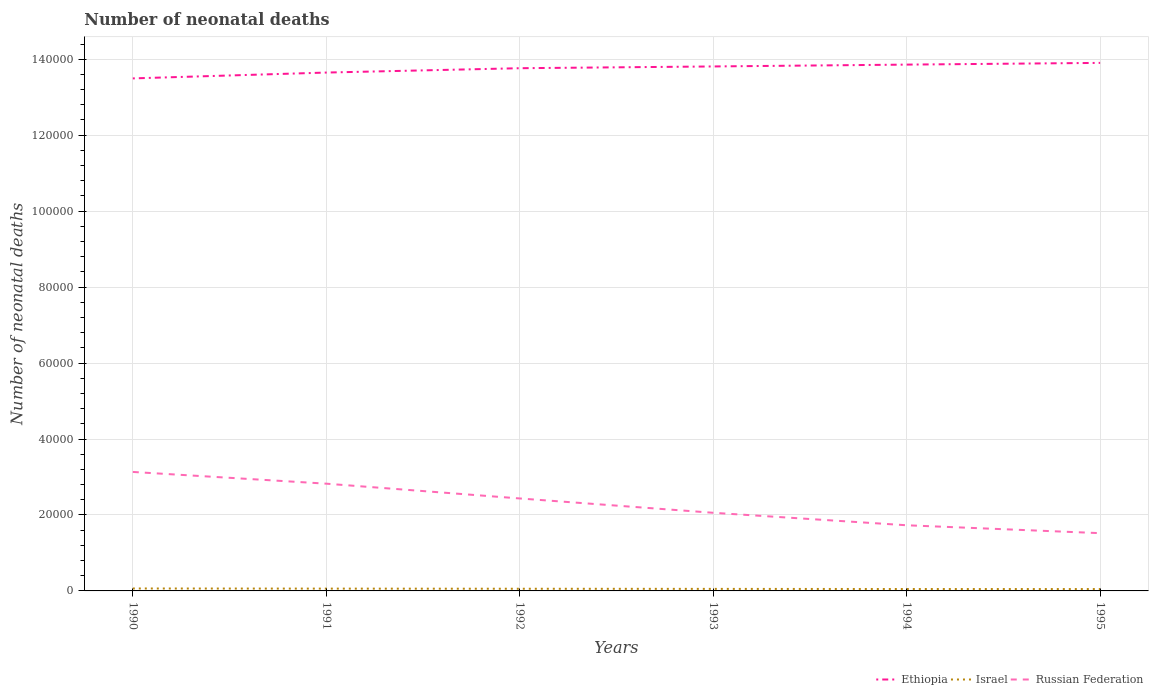How many different coloured lines are there?
Your answer should be very brief. 3. Across all years, what is the maximum number of neonatal deaths in in Israel?
Ensure brevity in your answer.  492. In which year was the number of neonatal deaths in in Israel maximum?
Provide a succinct answer. 1995. What is the total number of neonatal deaths in in Ethiopia in the graph?
Provide a succinct answer. -4085. What is the difference between the highest and the second highest number of neonatal deaths in in Israel?
Offer a very short reply. 151. Is the number of neonatal deaths in in Russian Federation strictly greater than the number of neonatal deaths in in Ethiopia over the years?
Ensure brevity in your answer.  Yes. How many lines are there?
Provide a short and direct response. 3. How many years are there in the graph?
Provide a short and direct response. 6. Are the values on the major ticks of Y-axis written in scientific E-notation?
Offer a very short reply. No. Does the graph contain any zero values?
Provide a short and direct response. No. Does the graph contain grids?
Your response must be concise. Yes. Where does the legend appear in the graph?
Provide a succinct answer. Bottom right. How are the legend labels stacked?
Offer a terse response. Horizontal. What is the title of the graph?
Give a very brief answer. Number of neonatal deaths. Does "Cote d'Ivoire" appear as one of the legend labels in the graph?
Your answer should be compact. No. What is the label or title of the X-axis?
Your response must be concise. Years. What is the label or title of the Y-axis?
Offer a very short reply. Number of neonatal deaths. What is the Number of neonatal deaths in Ethiopia in 1990?
Keep it short and to the point. 1.35e+05. What is the Number of neonatal deaths in Israel in 1990?
Offer a very short reply. 643. What is the Number of neonatal deaths in Russian Federation in 1990?
Offer a very short reply. 3.13e+04. What is the Number of neonatal deaths in Ethiopia in 1991?
Provide a short and direct response. 1.36e+05. What is the Number of neonatal deaths in Israel in 1991?
Your response must be concise. 607. What is the Number of neonatal deaths in Russian Federation in 1991?
Provide a succinct answer. 2.82e+04. What is the Number of neonatal deaths of Ethiopia in 1992?
Your response must be concise. 1.38e+05. What is the Number of neonatal deaths in Israel in 1992?
Keep it short and to the point. 572. What is the Number of neonatal deaths in Russian Federation in 1992?
Make the answer very short. 2.43e+04. What is the Number of neonatal deaths in Ethiopia in 1993?
Keep it short and to the point. 1.38e+05. What is the Number of neonatal deaths of Israel in 1993?
Your answer should be very brief. 536. What is the Number of neonatal deaths in Russian Federation in 1993?
Offer a very short reply. 2.06e+04. What is the Number of neonatal deaths in Ethiopia in 1994?
Give a very brief answer. 1.39e+05. What is the Number of neonatal deaths in Israel in 1994?
Your response must be concise. 502. What is the Number of neonatal deaths in Russian Federation in 1994?
Your answer should be compact. 1.73e+04. What is the Number of neonatal deaths in Ethiopia in 1995?
Offer a very short reply. 1.39e+05. What is the Number of neonatal deaths of Israel in 1995?
Ensure brevity in your answer.  492. What is the Number of neonatal deaths of Russian Federation in 1995?
Provide a succinct answer. 1.52e+04. Across all years, what is the maximum Number of neonatal deaths in Ethiopia?
Provide a succinct answer. 1.39e+05. Across all years, what is the maximum Number of neonatal deaths in Israel?
Make the answer very short. 643. Across all years, what is the maximum Number of neonatal deaths of Russian Federation?
Your answer should be very brief. 3.13e+04. Across all years, what is the minimum Number of neonatal deaths in Ethiopia?
Provide a succinct answer. 1.35e+05. Across all years, what is the minimum Number of neonatal deaths in Israel?
Ensure brevity in your answer.  492. Across all years, what is the minimum Number of neonatal deaths in Russian Federation?
Provide a succinct answer. 1.52e+04. What is the total Number of neonatal deaths of Ethiopia in the graph?
Your answer should be compact. 8.25e+05. What is the total Number of neonatal deaths in Israel in the graph?
Offer a very short reply. 3352. What is the total Number of neonatal deaths in Russian Federation in the graph?
Offer a terse response. 1.37e+05. What is the difference between the Number of neonatal deaths of Ethiopia in 1990 and that in 1991?
Keep it short and to the point. -1538. What is the difference between the Number of neonatal deaths of Israel in 1990 and that in 1991?
Offer a terse response. 36. What is the difference between the Number of neonatal deaths in Russian Federation in 1990 and that in 1991?
Ensure brevity in your answer.  3089. What is the difference between the Number of neonatal deaths in Ethiopia in 1990 and that in 1992?
Provide a short and direct response. -2683. What is the difference between the Number of neonatal deaths in Russian Federation in 1990 and that in 1992?
Your answer should be very brief. 6981. What is the difference between the Number of neonatal deaths of Ethiopia in 1990 and that in 1993?
Your response must be concise. -3147. What is the difference between the Number of neonatal deaths in Israel in 1990 and that in 1993?
Your answer should be very brief. 107. What is the difference between the Number of neonatal deaths of Russian Federation in 1990 and that in 1993?
Your answer should be compact. 1.08e+04. What is the difference between the Number of neonatal deaths of Ethiopia in 1990 and that in 1994?
Offer a very short reply. -3631. What is the difference between the Number of neonatal deaths in Israel in 1990 and that in 1994?
Your response must be concise. 141. What is the difference between the Number of neonatal deaths of Russian Federation in 1990 and that in 1994?
Make the answer very short. 1.40e+04. What is the difference between the Number of neonatal deaths of Ethiopia in 1990 and that in 1995?
Make the answer very short. -4085. What is the difference between the Number of neonatal deaths of Israel in 1990 and that in 1995?
Your answer should be very brief. 151. What is the difference between the Number of neonatal deaths of Russian Federation in 1990 and that in 1995?
Your answer should be compact. 1.61e+04. What is the difference between the Number of neonatal deaths in Ethiopia in 1991 and that in 1992?
Offer a terse response. -1145. What is the difference between the Number of neonatal deaths in Russian Federation in 1991 and that in 1992?
Give a very brief answer. 3892. What is the difference between the Number of neonatal deaths of Ethiopia in 1991 and that in 1993?
Your answer should be very brief. -1609. What is the difference between the Number of neonatal deaths of Russian Federation in 1991 and that in 1993?
Provide a short and direct response. 7664. What is the difference between the Number of neonatal deaths in Ethiopia in 1991 and that in 1994?
Keep it short and to the point. -2093. What is the difference between the Number of neonatal deaths in Israel in 1991 and that in 1994?
Your response must be concise. 105. What is the difference between the Number of neonatal deaths in Russian Federation in 1991 and that in 1994?
Your answer should be compact. 1.10e+04. What is the difference between the Number of neonatal deaths of Ethiopia in 1991 and that in 1995?
Make the answer very short. -2547. What is the difference between the Number of neonatal deaths in Israel in 1991 and that in 1995?
Make the answer very short. 115. What is the difference between the Number of neonatal deaths of Russian Federation in 1991 and that in 1995?
Make the answer very short. 1.30e+04. What is the difference between the Number of neonatal deaths in Ethiopia in 1992 and that in 1993?
Your answer should be very brief. -464. What is the difference between the Number of neonatal deaths of Russian Federation in 1992 and that in 1993?
Keep it short and to the point. 3772. What is the difference between the Number of neonatal deaths in Ethiopia in 1992 and that in 1994?
Provide a short and direct response. -948. What is the difference between the Number of neonatal deaths in Russian Federation in 1992 and that in 1994?
Provide a succinct answer. 7059. What is the difference between the Number of neonatal deaths of Ethiopia in 1992 and that in 1995?
Provide a succinct answer. -1402. What is the difference between the Number of neonatal deaths in Russian Federation in 1992 and that in 1995?
Offer a very short reply. 9137. What is the difference between the Number of neonatal deaths in Ethiopia in 1993 and that in 1994?
Keep it short and to the point. -484. What is the difference between the Number of neonatal deaths of Russian Federation in 1993 and that in 1994?
Your answer should be compact. 3287. What is the difference between the Number of neonatal deaths of Ethiopia in 1993 and that in 1995?
Provide a short and direct response. -938. What is the difference between the Number of neonatal deaths of Russian Federation in 1993 and that in 1995?
Give a very brief answer. 5365. What is the difference between the Number of neonatal deaths of Ethiopia in 1994 and that in 1995?
Your answer should be compact. -454. What is the difference between the Number of neonatal deaths of Russian Federation in 1994 and that in 1995?
Provide a short and direct response. 2078. What is the difference between the Number of neonatal deaths of Ethiopia in 1990 and the Number of neonatal deaths of Israel in 1991?
Provide a succinct answer. 1.34e+05. What is the difference between the Number of neonatal deaths of Ethiopia in 1990 and the Number of neonatal deaths of Russian Federation in 1991?
Offer a very short reply. 1.07e+05. What is the difference between the Number of neonatal deaths in Israel in 1990 and the Number of neonatal deaths in Russian Federation in 1991?
Ensure brevity in your answer.  -2.76e+04. What is the difference between the Number of neonatal deaths in Ethiopia in 1990 and the Number of neonatal deaths in Israel in 1992?
Ensure brevity in your answer.  1.34e+05. What is the difference between the Number of neonatal deaths of Ethiopia in 1990 and the Number of neonatal deaths of Russian Federation in 1992?
Make the answer very short. 1.11e+05. What is the difference between the Number of neonatal deaths of Israel in 1990 and the Number of neonatal deaths of Russian Federation in 1992?
Keep it short and to the point. -2.37e+04. What is the difference between the Number of neonatal deaths of Ethiopia in 1990 and the Number of neonatal deaths of Israel in 1993?
Provide a short and direct response. 1.34e+05. What is the difference between the Number of neonatal deaths in Ethiopia in 1990 and the Number of neonatal deaths in Russian Federation in 1993?
Provide a succinct answer. 1.14e+05. What is the difference between the Number of neonatal deaths of Israel in 1990 and the Number of neonatal deaths of Russian Federation in 1993?
Give a very brief answer. -1.99e+04. What is the difference between the Number of neonatal deaths in Ethiopia in 1990 and the Number of neonatal deaths in Israel in 1994?
Your response must be concise. 1.34e+05. What is the difference between the Number of neonatal deaths of Ethiopia in 1990 and the Number of neonatal deaths of Russian Federation in 1994?
Your answer should be compact. 1.18e+05. What is the difference between the Number of neonatal deaths in Israel in 1990 and the Number of neonatal deaths in Russian Federation in 1994?
Your answer should be compact. -1.66e+04. What is the difference between the Number of neonatal deaths in Ethiopia in 1990 and the Number of neonatal deaths in Israel in 1995?
Your answer should be compact. 1.34e+05. What is the difference between the Number of neonatal deaths in Ethiopia in 1990 and the Number of neonatal deaths in Russian Federation in 1995?
Make the answer very short. 1.20e+05. What is the difference between the Number of neonatal deaths in Israel in 1990 and the Number of neonatal deaths in Russian Federation in 1995?
Provide a short and direct response. -1.46e+04. What is the difference between the Number of neonatal deaths in Ethiopia in 1991 and the Number of neonatal deaths in Israel in 1992?
Ensure brevity in your answer.  1.36e+05. What is the difference between the Number of neonatal deaths in Ethiopia in 1991 and the Number of neonatal deaths in Russian Federation in 1992?
Keep it short and to the point. 1.12e+05. What is the difference between the Number of neonatal deaths of Israel in 1991 and the Number of neonatal deaths of Russian Federation in 1992?
Keep it short and to the point. -2.37e+04. What is the difference between the Number of neonatal deaths of Ethiopia in 1991 and the Number of neonatal deaths of Israel in 1993?
Provide a short and direct response. 1.36e+05. What is the difference between the Number of neonatal deaths of Ethiopia in 1991 and the Number of neonatal deaths of Russian Federation in 1993?
Your response must be concise. 1.16e+05. What is the difference between the Number of neonatal deaths in Israel in 1991 and the Number of neonatal deaths in Russian Federation in 1993?
Provide a succinct answer. -2.00e+04. What is the difference between the Number of neonatal deaths in Ethiopia in 1991 and the Number of neonatal deaths in Israel in 1994?
Offer a very short reply. 1.36e+05. What is the difference between the Number of neonatal deaths of Ethiopia in 1991 and the Number of neonatal deaths of Russian Federation in 1994?
Ensure brevity in your answer.  1.19e+05. What is the difference between the Number of neonatal deaths in Israel in 1991 and the Number of neonatal deaths in Russian Federation in 1994?
Your answer should be compact. -1.67e+04. What is the difference between the Number of neonatal deaths of Ethiopia in 1991 and the Number of neonatal deaths of Israel in 1995?
Make the answer very short. 1.36e+05. What is the difference between the Number of neonatal deaths of Ethiopia in 1991 and the Number of neonatal deaths of Russian Federation in 1995?
Provide a succinct answer. 1.21e+05. What is the difference between the Number of neonatal deaths of Israel in 1991 and the Number of neonatal deaths of Russian Federation in 1995?
Offer a terse response. -1.46e+04. What is the difference between the Number of neonatal deaths in Ethiopia in 1992 and the Number of neonatal deaths in Israel in 1993?
Provide a short and direct response. 1.37e+05. What is the difference between the Number of neonatal deaths in Ethiopia in 1992 and the Number of neonatal deaths in Russian Federation in 1993?
Your response must be concise. 1.17e+05. What is the difference between the Number of neonatal deaths of Israel in 1992 and the Number of neonatal deaths of Russian Federation in 1993?
Keep it short and to the point. -2.00e+04. What is the difference between the Number of neonatal deaths in Ethiopia in 1992 and the Number of neonatal deaths in Israel in 1994?
Your answer should be very brief. 1.37e+05. What is the difference between the Number of neonatal deaths in Ethiopia in 1992 and the Number of neonatal deaths in Russian Federation in 1994?
Provide a succinct answer. 1.20e+05. What is the difference between the Number of neonatal deaths in Israel in 1992 and the Number of neonatal deaths in Russian Federation in 1994?
Your answer should be very brief. -1.67e+04. What is the difference between the Number of neonatal deaths of Ethiopia in 1992 and the Number of neonatal deaths of Israel in 1995?
Keep it short and to the point. 1.37e+05. What is the difference between the Number of neonatal deaths of Ethiopia in 1992 and the Number of neonatal deaths of Russian Federation in 1995?
Keep it short and to the point. 1.22e+05. What is the difference between the Number of neonatal deaths of Israel in 1992 and the Number of neonatal deaths of Russian Federation in 1995?
Your answer should be compact. -1.46e+04. What is the difference between the Number of neonatal deaths of Ethiopia in 1993 and the Number of neonatal deaths of Israel in 1994?
Give a very brief answer. 1.38e+05. What is the difference between the Number of neonatal deaths in Ethiopia in 1993 and the Number of neonatal deaths in Russian Federation in 1994?
Your answer should be very brief. 1.21e+05. What is the difference between the Number of neonatal deaths in Israel in 1993 and the Number of neonatal deaths in Russian Federation in 1994?
Provide a succinct answer. -1.68e+04. What is the difference between the Number of neonatal deaths in Ethiopia in 1993 and the Number of neonatal deaths in Israel in 1995?
Your answer should be compact. 1.38e+05. What is the difference between the Number of neonatal deaths in Ethiopia in 1993 and the Number of neonatal deaths in Russian Federation in 1995?
Provide a succinct answer. 1.23e+05. What is the difference between the Number of neonatal deaths of Israel in 1993 and the Number of neonatal deaths of Russian Federation in 1995?
Ensure brevity in your answer.  -1.47e+04. What is the difference between the Number of neonatal deaths in Ethiopia in 1994 and the Number of neonatal deaths in Israel in 1995?
Your answer should be compact. 1.38e+05. What is the difference between the Number of neonatal deaths of Ethiopia in 1994 and the Number of neonatal deaths of Russian Federation in 1995?
Keep it short and to the point. 1.23e+05. What is the difference between the Number of neonatal deaths in Israel in 1994 and the Number of neonatal deaths in Russian Federation in 1995?
Make the answer very short. -1.47e+04. What is the average Number of neonatal deaths in Ethiopia per year?
Provide a succinct answer. 1.37e+05. What is the average Number of neonatal deaths of Israel per year?
Offer a very short reply. 558.67. What is the average Number of neonatal deaths in Russian Federation per year?
Provide a succinct answer. 2.28e+04. In the year 1990, what is the difference between the Number of neonatal deaths of Ethiopia and Number of neonatal deaths of Israel?
Ensure brevity in your answer.  1.34e+05. In the year 1990, what is the difference between the Number of neonatal deaths in Ethiopia and Number of neonatal deaths in Russian Federation?
Make the answer very short. 1.04e+05. In the year 1990, what is the difference between the Number of neonatal deaths of Israel and Number of neonatal deaths of Russian Federation?
Your answer should be very brief. -3.07e+04. In the year 1991, what is the difference between the Number of neonatal deaths of Ethiopia and Number of neonatal deaths of Israel?
Your response must be concise. 1.36e+05. In the year 1991, what is the difference between the Number of neonatal deaths of Ethiopia and Number of neonatal deaths of Russian Federation?
Provide a succinct answer. 1.08e+05. In the year 1991, what is the difference between the Number of neonatal deaths of Israel and Number of neonatal deaths of Russian Federation?
Give a very brief answer. -2.76e+04. In the year 1992, what is the difference between the Number of neonatal deaths of Ethiopia and Number of neonatal deaths of Israel?
Offer a terse response. 1.37e+05. In the year 1992, what is the difference between the Number of neonatal deaths of Ethiopia and Number of neonatal deaths of Russian Federation?
Provide a short and direct response. 1.13e+05. In the year 1992, what is the difference between the Number of neonatal deaths in Israel and Number of neonatal deaths in Russian Federation?
Provide a succinct answer. -2.38e+04. In the year 1993, what is the difference between the Number of neonatal deaths in Ethiopia and Number of neonatal deaths in Israel?
Provide a succinct answer. 1.38e+05. In the year 1993, what is the difference between the Number of neonatal deaths in Ethiopia and Number of neonatal deaths in Russian Federation?
Offer a terse response. 1.18e+05. In the year 1993, what is the difference between the Number of neonatal deaths of Israel and Number of neonatal deaths of Russian Federation?
Provide a succinct answer. -2.00e+04. In the year 1994, what is the difference between the Number of neonatal deaths in Ethiopia and Number of neonatal deaths in Israel?
Give a very brief answer. 1.38e+05. In the year 1994, what is the difference between the Number of neonatal deaths in Ethiopia and Number of neonatal deaths in Russian Federation?
Your answer should be compact. 1.21e+05. In the year 1994, what is the difference between the Number of neonatal deaths in Israel and Number of neonatal deaths in Russian Federation?
Your response must be concise. -1.68e+04. In the year 1995, what is the difference between the Number of neonatal deaths in Ethiopia and Number of neonatal deaths in Israel?
Provide a succinct answer. 1.39e+05. In the year 1995, what is the difference between the Number of neonatal deaths in Ethiopia and Number of neonatal deaths in Russian Federation?
Ensure brevity in your answer.  1.24e+05. In the year 1995, what is the difference between the Number of neonatal deaths of Israel and Number of neonatal deaths of Russian Federation?
Make the answer very short. -1.47e+04. What is the ratio of the Number of neonatal deaths in Ethiopia in 1990 to that in 1991?
Ensure brevity in your answer.  0.99. What is the ratio of the Number of neonatal deaths in Israel in 1990 to that in 1991?
Provide a succinct answer. 1.06. What is the ratio of the Number of neonatal deaths in Russian Federation in 1990 to that in 1991?
Your answer should be compact. 1.11. What is the ratio of the Number of neonatal deaths of Ethiopia in 1990 to that in 1992?
Offer a very short reply. 0.98. What is the ratio of the Number of neonatal deaths in Israel in 1990 to that in 1992?
Provide a short and direct response. 1.12. What is the ratio of the Number of neonatal deaths of Russian Federation in 1990 to that in 1992?
Give a very brief answer. 1.29. What is the ratio of the Number of neonatal deaths of Ethiopia in 1990 to that in 1993?
Keep it short and to the point. 0.98. What is the ratio of the Number of neonatal deaths in Israel in 1990 to that in 1993?
Make the answer very short. 1.2. What is the ratio of the Number of neonatal deaths in Russian Federation in 1990 to that in 1993?
Offer a very short reply. 1.52. What is the ratio of the Number of neonatal deaths of Ethiopia in 1990 to that in 1994?
Ensure brevity in your answer.  0.97. What is the ratio of the Number of neonatal deaths of Israel in 1990 to that in 1994?
Give a very brief answer. 1.28. What is the ratio of the Number of neonatal deaths of Russian Federation in 1990 to that in 1994?
Keep it short and to the point. 1.81. What is the ratio of the Number of neonatal deaths of Ethiopia in 1990 to that in 1995?
Provide a succinct answer. 0.97. What is the ratio of the Number of neonatal deaths in Israel in 1990 to that in 1995?
Ensure brevity in your answer.  1.31. What is the ratio of the Number of neonatal deaths in Russian Federation in 1990 to that in 1995?
Your answer should be compact. 2.06. What is the ratio of the Number of neonatal deaths in Ethiopia in 1991 to that in 1992?
Offer a very short reply. 0.99. What is the ratio of the Number of neonatal deaths in Israel in 1991 to that in 1992?
Provide a succinct answer. 1.06. What is the ratio of the Number of neonatal deaths in Russian Federation in 1991 to that in 1992?
Provide a short and direct response. 1.16. What is the ratio of the Number of neonatal deaths in Ethiopia in 1991 to that in 1993?
Give a very brief answer. 0.99. What is the ratio of the Number of neonatal deaths of Israel in 1991 to that in 1993?
Keep it short and to the point. 1.13. What is the ratio of the Number of neonatal deaths of Russian Federation in 1991 to that in 1993?
Offer a terse response. 1.37. What is the ratio of the Number of neonatal deaths of Ethiopia in 1991 to that in 1994?
Offer a very short reply. 0.98. What is the ratio of the Number of neonatal deaths in Israel in 1991 to that in 1994?
Give a very brief answer. 1.21. What is the ratio of the Number of neonatal deaths of Russian Federation in 1991 to that in 1994?
Your answer should be compact. 1.63. What is the ratio of the Number of neonatal deaths in Ethiopia in 1991 to that in 1995?
Give a very brief answer. 0.98. What is the ratio of the Number of neonatal deaths in Israel in 1991 to that in 1995?
Keep it short and to the point. 1.23. What is the ratio of the Number of neonatal deaths of Russian Federation in 1991 to that in 1995?
Ensure brevity in your answer.  1.86. What is the ratio of the Number of neonatal deaths in Israel in 1992 to that in 1993?
Offer a terse response. 1.07. What is the ratio of the Number of neonatal deaths in Russian Federation in 1992 to that in 1993?
Provide a short and direct response. 1.18. What is the ratio of the Number of neonatal deaths in Ethiopia in 1992 to that in 1994?
Give a very brief answer. 0.99. What is the ratio of the Number of neonatal deaths in Israel in 1992 to that in 1994?
Make the answer very short. 1.14. What is the ratio of the Number of neonatal deaths in Russian Federation in 1992 to that in 1994?
Offer a terse response. 1.41. What is the ratio of the Number of neonatal deaths in Ethiopia in 1992 to that in 1995?
Make the answer very short. 0.99. What is the ratio of the Number of neonatal deaths of Israel in 1992 to that in 1995?
Your answer should be very brief. 1.16. What is the ratio of the Number of neonatal deaths of Russian Federation in 1992 to that in 1995?
Your response must be concise. 1.6. What is the ratio of the Number of neonatal deaths in Ethiopia in 1993 to that in 1994?
Offer a terse response. 1. What is the ratio of the Number of neonatal deaths in Israel in 1993 to that in 1994?
Ensure brevity in your answer.  1.07. What is the ratio of the Number of neonatal deaths of Russian Federation in 1993 to that in 1994?
Your response must be concise. 1.19. What is the ratio of the Number of neonatal deaths of Ethiopia in 1993 to that in 1995?
Your answer should be very brief. 0.99. What is the ratio of the Number of neonatal deaths in Israel in 1993 to that in 1995?
Your answer should be very brief. 1.09. What is the ratio of the Number of neonatal deaths of Russian Federation in 1993 to that in 1995?
Offer a terse response. 1.35. What is the ratio of the Number of neonatal deaths in Ethiopia in 1994 to that in 1995?
Make the answer very short. 1. What is the ratio of the Number of neonatal deaths of Israel in 1994 to that in 1995?
Your response must be concise. 1.02. What is the ratio of the Number of neonatal deaths of Russian Federation in 1994 to that in 1995?
Your answer should be compact. 1.14. What is the difference between the highest and the second highest Number of neonatal deaths in Ethiopia?
Your answer should be compact. 454. What is the difference between the highest and the second highest Number of neonatal deaths of Russian Federation?
Your answer should be compact. 3089. What is the difference between the highest and the lowest Number of neonatal deaths in Ethiopia?
Offer a very short reply. 4085. What is the difference between the highest and the lowest Number of neonatal deaths in Israel?
Offer a terse response. 151. What is the difference between the highest and the lowest Number of neonatal deaths of Russian Federation?
Ensure brevity in your answer.  1.61e+04. 